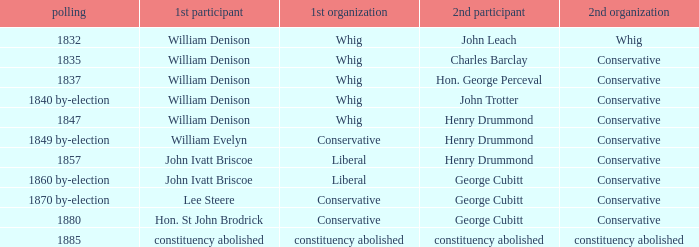Which party's 1st member is John Ivatt Briscoe in an election in 1857? Liberal. 